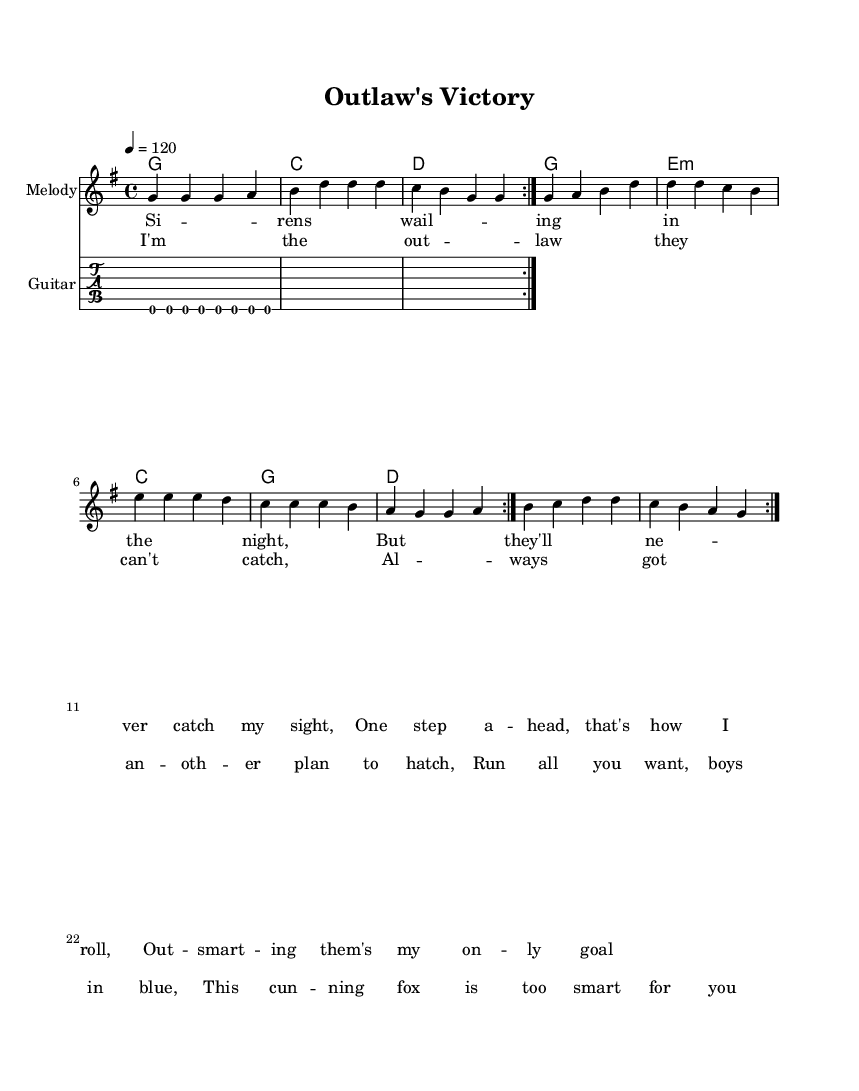What is the key signature of this music? The key signature is G major, which contains one sharp (F#). This can be identified by looking at the key signature indicated at the beginning of the music sheet.
Answer: G major What is the time signature of this piece? The time signature is 4/4, which is indicated at the beginning of the sheet with a "4 over 4". This means there are four beats in a measure and the quarter note gets one beat.
Answer: 4/4 What is the tempo markings for this composition? The tempo marking is 120 beats per minute, which is specified in the score as "4 = 120". This indicates the speed at which the piece should be played.
Answer: 120 How many times is the melody section repeated? The melody section is repeated twice, indicated by the "repeat volta 2" sign in the notation. This tells the performer to play the melody two times before moving to the next section.
Answer: 2 What is the primary theme of the lyrics in this song? The primary theme of the lyrics revolves around outsmarting law enforcement, as expressed in phrases like "outsmarting them's my only goal" and "this cunning fox is too smart for you". This significantly reflects the song's context in the genre of Southern rock anthems.
Answer: Outsmarting law enforcement What chord follows the first measure of the melody? The chord that follows the first measure of the melody is G major, which can be seen at the beginning of the chord progression represented in the chord names section.
Answer: G What instrument is designated for the riff in this arrangement? The riff is designated for the guitar, indicated by the "Guitar" label on the TabStaff section throughout the sheet music. This specific notation allows guitarists to follow along with the melody and chords.
Answer: Guitar 